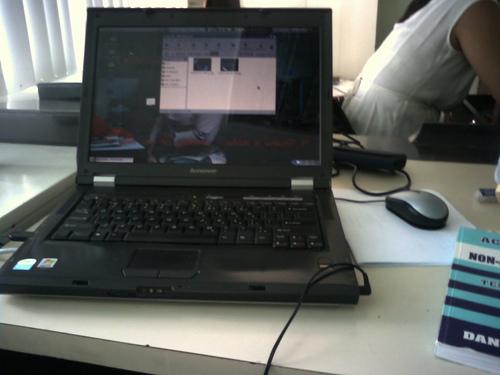What color are the blinds?
Keep it brief. White. Is the mouse wireless?
Write a very short answer. No. Is the laptop turned on?
Quick response, please. Yes. Is the laptop plugged in?
Concise answer only. Yes. 